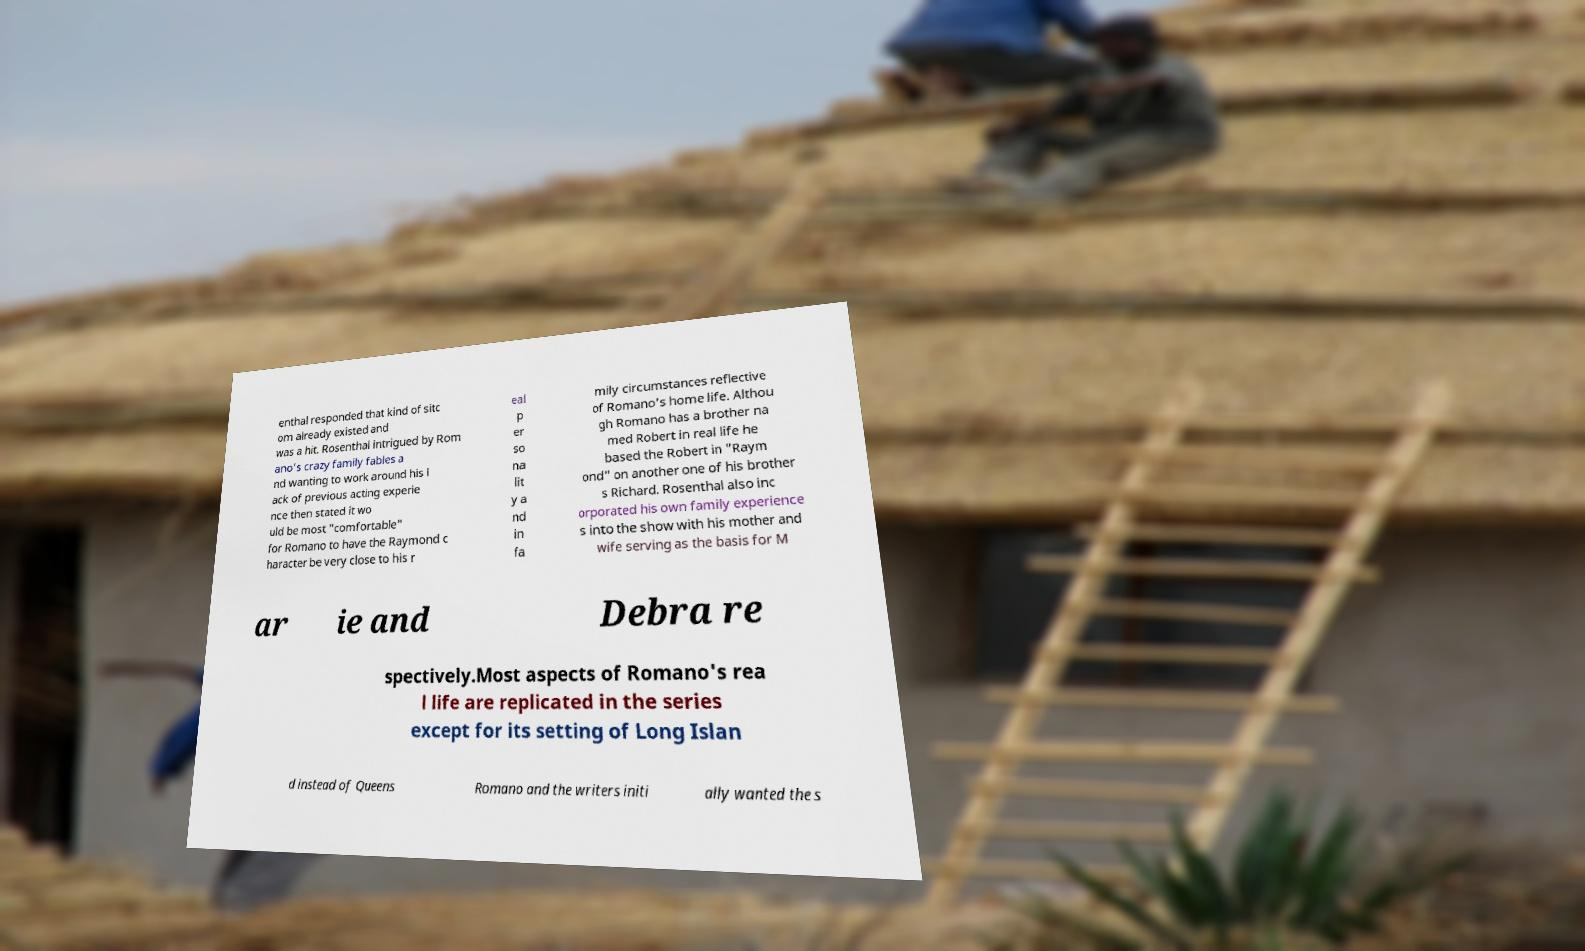Can you read and provide the text displayed in the image?This photo seems to have some interesting text. Can you extract and type it out for me? enthal responded that kind of sitc om already existed and was a hit. Rosenthal intrigued by Rom ano's crazy family fables a nd wanting to work around his l ack of previous acting experie nce then stated it wo uld be most "comfortable" for Romano to have the Raymond c haracter be very close to his r eal p er so na lit y a nd in fa mily circumstances reflective of Romano's home life. Althou gh Romano has a brother na med Robert in real life he based the Robert in "Raym ond" on another one of his brother s Richard. Rosenthal also inc orporated his own family experience s into the show with his mother and wife serving as the basis for M ar ie and Debra re spectively.Most aspects of Romano's rea l life are replicated in the series except for its setting of Long Islan d instead of Queens Romano and the writers initi ally wanted the s 